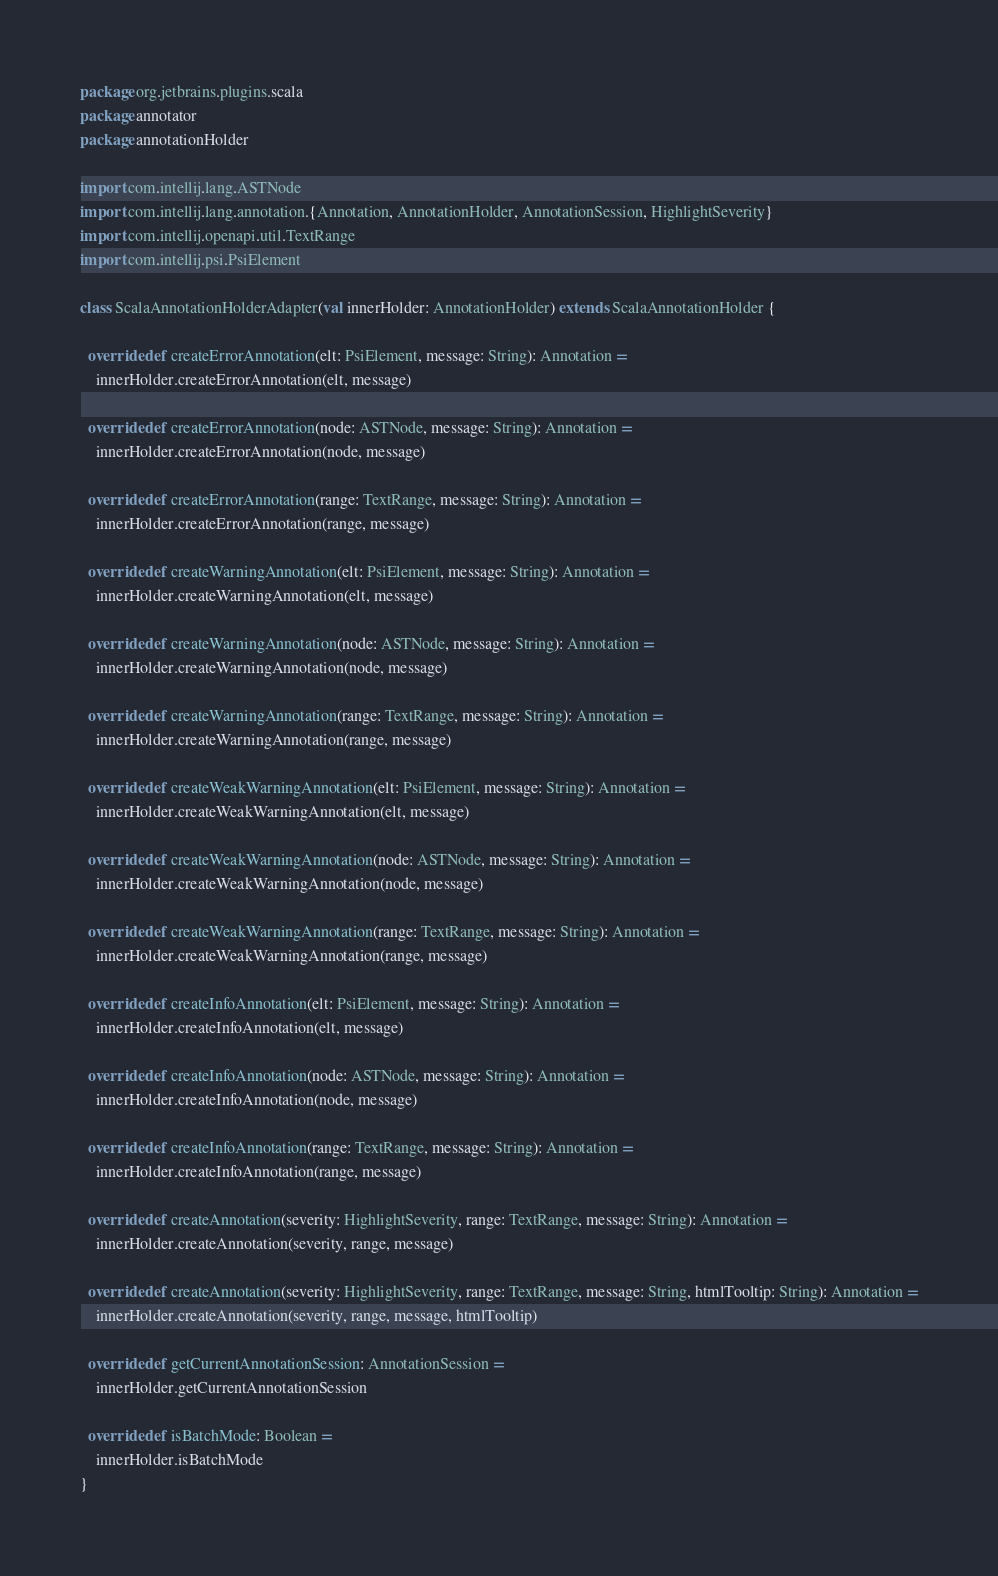<code> <loc_0><loc_0><loc_500><loc_500><_Scala_>package org.jetbrains.plugins.scala
package annotator
package annotationHolder

import com.intellij.lang.ASTNode
import com.intellij.lang.annotation.{Annotation, AnnotationHolder, AnnotationSession, HighlightSeverity}
import com.intellij.openapi.util.TextRange
import com.intellij.psi.PsiElement

class ScalaAnnotationHolderAdapter(val innerHolder: AnnotationHolder) extends ScalaAnnotationHolder {

  override def createErrorAnnotation(elt: PsiElement, message: String): Annotation =
    innerHolder.createErrorAnnotation(elt, message)

  override def createErrorAnnotation(node: ASTNode, message: String): Annotation =
    innerHolder.createErrorAnnotation(node, message)

  override def createErrorAnnotation(range: TextRange, message: String): Annotation =
    innerHolder.createErrorAnnotation(range, message)

  override def createWarningAnnotation(elt: PsiElement, message: String): Annotation =
    innerHolder.createWarningAnnotation(elt, message)

  override def createWarningAnnotation(node: ASTNode, message: String): Annotation =
    innerHolder.createWarningAnnotation(node, message)

  override def createWarningAnnotation(range: TextRange, message: String): Annotation =
    innerHolder.createWarningAnnotation(range, message)

  override def createWeakWarningAnnotation(elt: PsiElement, message: String): Annotation =
    innerHolder.createWeakWarningAnnotation(elt, message)

  override def createWeakWarningAnnotation(node: ASTNode, message: String): Annotation =
    innerHolder.createWeakWarningAnnotation(node, message)

  override def createWeakWarningAnnotation(range: TextRange, message: String): Annotation =
    innerHolder.createWeakWarningAnnotation(range, message)

  override def createInfoAnnotation(elt: PsiElement, message: String): Annotation =
    innerHolder.createInfoAnnotation(elt, message)

  override def createInfoAnnotation(node: ASTNode, message: String): Annotation =
    innerHolder.createInfoAnnotation(node, message)

  override def createInfoAnnotation(range: TextRange, message: String): Annotation =
    innerHolder.createInfoAnnotation(range, message)

  override def createAnnotation(severity: HighlightSeverity, range: TextRange, message: String): Annotation =
    innerHolder.createAnnotation(severity, range, message)

  override def createAnnotation(severity: HighlightSeverity, range: TextRange, message: String, htmlTooltip: String): Annotation =
    innerHolder.createAnnotation(severity, range, message, htmlTooltip)

  override def getCurrentAnnotationSession: AnnotationSession =
    innerHolder.getCurrentAnnotationSession

  override def isBatchMode: Boolean =
    innerHolder.isBatchMode
}
</code> 